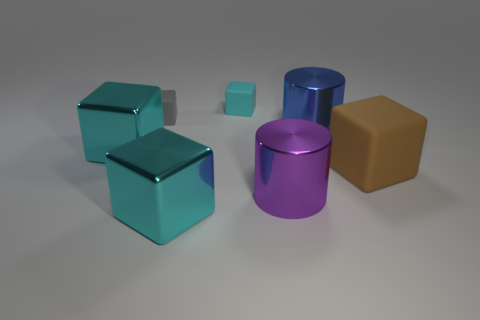The gray object has what size?
Your answer should be compact. Small. Is the material of the cyan object behind the blue thing the same as the big blue object?
Provide a succinct answer. No. How many things are big brown objects or cyan things on the left side of the cyan rubber block?
Your response must be concise. 3. There is another gray thing that is the same shape as the large matte thing; what size is it?
Give a very brief answer. Small. Is there anything else that has the same size as the purple shiny cylinder?
Your response must be concise. Yes. Are there any large purple objects on the left side of the purple object?
Provide a short and direct response. No. Does the big metal cylinder behind the big brown matte object have the same color as the small matte object in front of the cyan rubber cube?
Your answer should be very brief. No. Are there any cyan objects of the same shape as the blue metallic thing?
Your answer should be very brief. No. What number of other objects are there of the same color as the big rubber thing?
Offer a very short reply. 0. The matte cube that is left of the cyan block that is right of the cyan shiny cube that is in front of the brown block is what color?
Your response must be concise. Gray. 